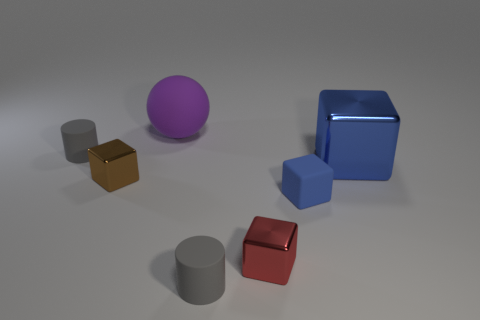Add 1 yellow matte cylinders. How many objects exist? 8 Subtract all matte cubes. How many cubes are left? 3 Subtract all red cubes. How many cubes are left? 3 Subtract all blue spheres. How many blue cubes are left? 2 Subtract 3 cubes. How many cubes are left? 1 Subtract all cylinders. How many objects are left? 5 Subtract all yellow cylinders. Subtract all purple spheres. How many cylinders are left? 2 Subtract all small gray cubes. Subtract all brown things. How many objects are left? 6 Add 6 small matte objects. How many small matte objects are left? 9 Add 2 small blue objects. How many small blue objects exist? 3 